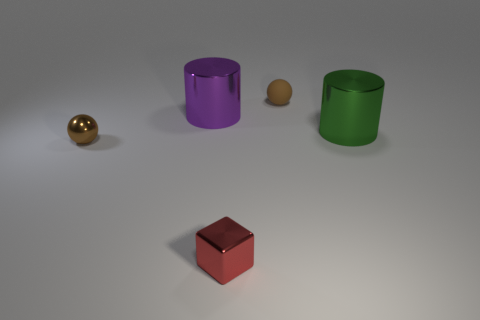There is another small object that is the same color as the rubber object; what is its shape?
Ensure brevity in your answer.  Sphere. Is there a tiny green cylinder made of the same material as the green thing?
Make the answer very short. No. The tiny rubber thing has what shape?
Offer a terse response. Sphere. How many shiny things are there?
Your answer should be compact. 4. What color is the large metallic cylinder that is on the left side of the small thing behind the big green cylinder?
Offer a terse response. Purple. There is another metal thing that is the same size as the green shiny thing; what color is it?
Provide a short and direct response. Purple. Are there any things of the same color as the metallic cube?
Keep it short and to the point. No. Are there any small objects?
Offer a very short reply. Yes. What is the shape of the small brown thing that is on the left side of the brown rubber ball?
Ensure brevity in your answer.  Sphere. What number of things are both to the right of the large purple cylinder and to the left of the green cylinder?
Give a very brief answer. 2. 